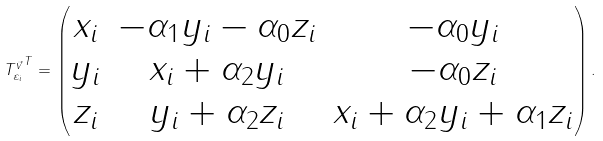Convert formula to latex. <formula><loc_0><loc_0><loc_500><loc_500>{ T _ { \varepsilon _ { i } } ^ { \vec { v } } } ^ { T } = \begin{pmatrix} x _ { i } & - \alpha _ { 1 } y _ { i } - \alpha _ { 0 } z _ { i } & - \alpha _ { 0 } y _ { i } \\ y _ { i } & x _ { i } + \alpha _ { 2 } y _ { i } & - \alpha _ { 0 } z _ { i } \\ z _ { i } & y _ { i } + \alpha _ { 2 } z _ { i } & x _ { i } + \alpha _ { 2 } y _ { i } + \alpha _ { 1 } z _ { i } \end{pmatrix} .</formula> 